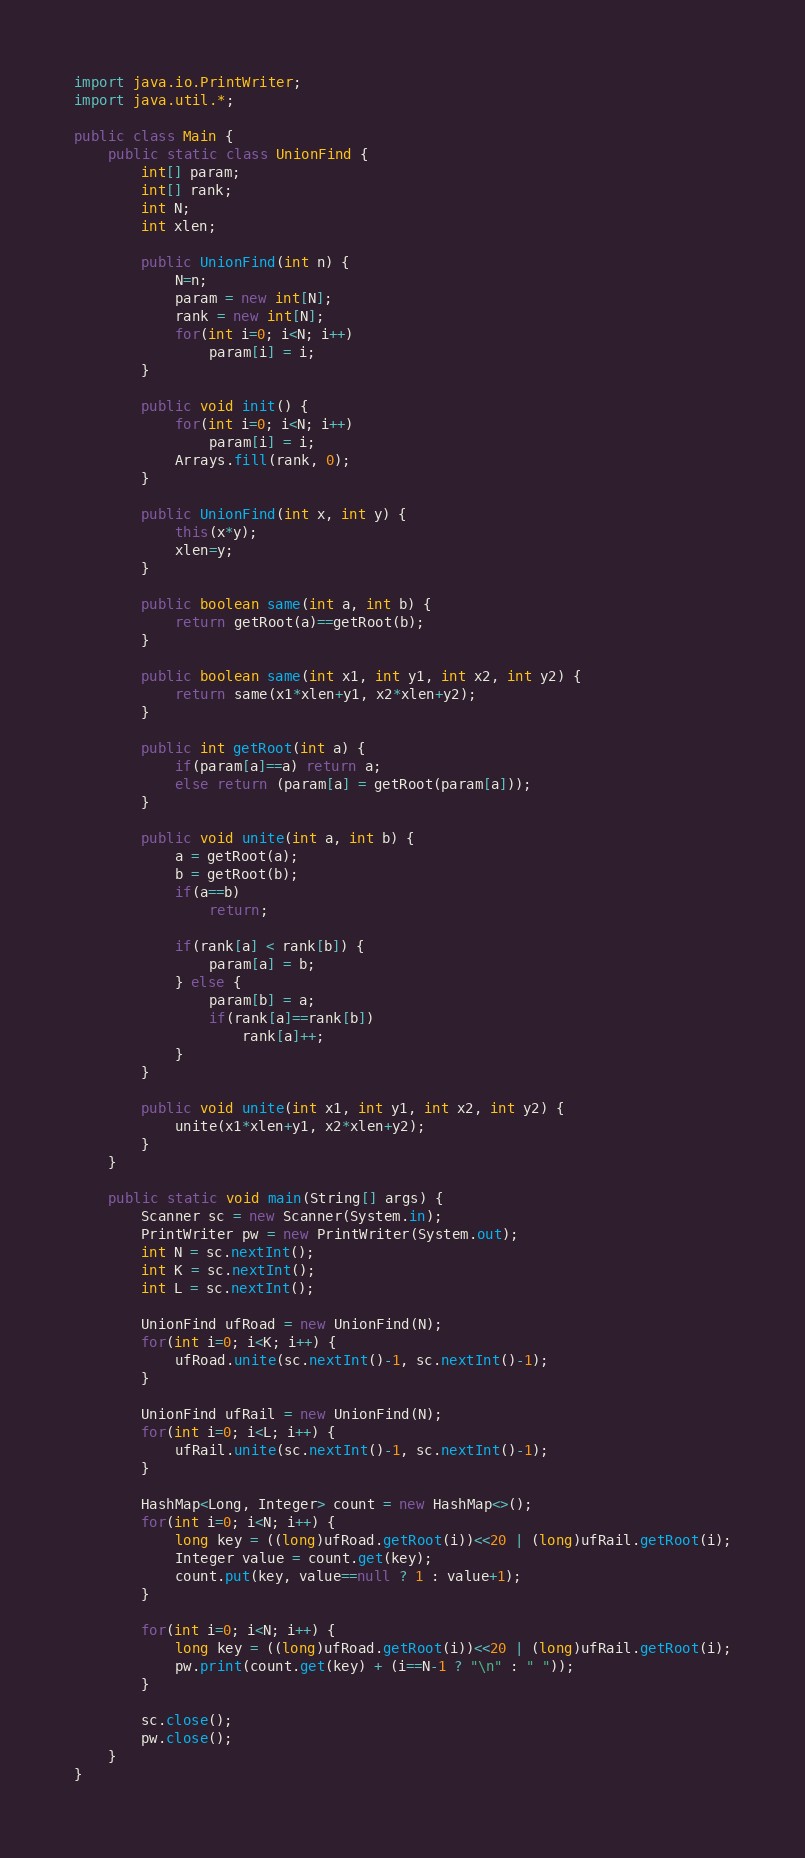Convert code to text. <code><loc_0><loc_0><loc_500><loc_500><_Java_>import java.io.PrintWriter;
import java.util.*;

public class Main {
	public static class UnionFind {
		int[] param;
		int[] rank;
		int N;
		int xlen;
		
		public UnionFind(int n) {
			N=n;
			param = new int[N];
			rank = new int[N];
			for(int i=0; i<N; i++)
				param[i] = i;
		}
		
		public void init() {
			for(int i=0; i<N; i++)
				param[i] = i;
			Arrays.fill(rank, 0);
		}
		
		public UnionFind(int x, int y) {
			this(x*y);
			xlen=y;
		}
		
		public boolean same(int a, int b) {
			return getRoot(a)==getRoot(b);
		}
		
		public boolean same(int x1, int y1, int x2, int y2) {
			return same(x1*xlen+y1, x2*xlen+y2);
		}
		
		public int getRoot(int a) {
			if(param[a]==a) return a;
			else return (param[a] = getRoot(param[a]));
		}
		
		public void unite(int a, int b) {
			a = getRoot(a);
			b = getRoot(b);
			if(a==b)
				return;
			
			if(rank[a] < rank[b]) {
				param[a] = b;
			} else {
				param[b] = a;
				if(rank[a]==rank[b])
					rank[a]++;
			}
		}
		
		public void unite(int x1, int y1, int x2, int y2) {
			unite(x1*xlen+y1, x2*xlen+y2);
		}
	}

	public static void main(String[] args) {
		Scanner sc = new Scanner(System.in);
		PrintWriter pw = new PrintWriter(System.out);
		int N = sc.nextInt();
		int K = sc.nextInt();
		int L = sc.nextInt();
		
		UnionFind ufRoad = new UnionFind(N);
		for(int i=0; i<K; i++) {
			ufRoad.unite(sc.nextInt()-1, sc.nextInt()-1);
		}

		UnionFind ufRail = new UnionFind(N);
		for(int i=0; i<L; i++) {
			ufRail.unite(sc.nextInt()-1, sc.nextInt()-1);
		}
		
		HashMap<Long, Integer> count = new HashMap<>();
		for(int i=0; i<N; i++) {
			long key = ((long)ufRoad.getRoot(i))<<20 | (long)ufRail.getRoot(i);
			Integer value = count.get(key);
			count.put(key, value==null ? 1 : value+1);
		}
		
		for(int i=0; i<N; i++) {
			long key = ((long)ufRoad.getRoot(i))<<20 | (long)ufRail.getRoot(i);
			pw.print(count.get(key) + (i==N-1 ? "\n" : " "));
		}
		
		sc.close();
		pw.close();
	}
}
</code> 